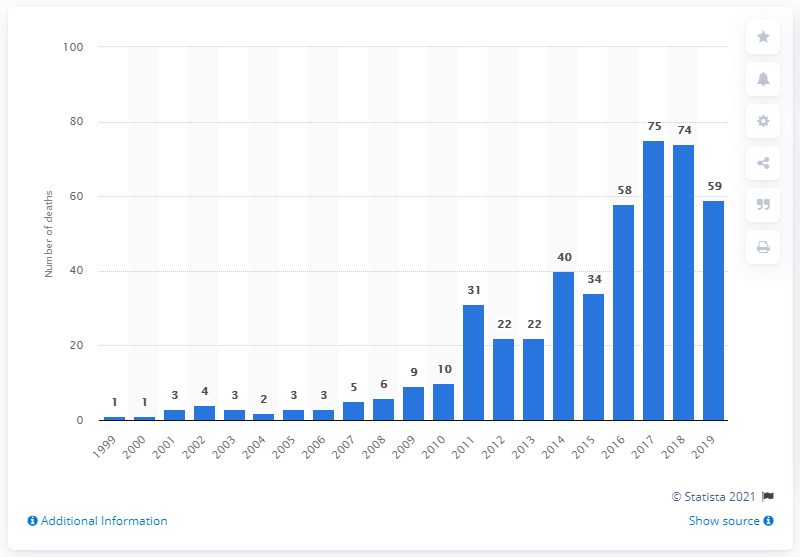Mention a couple of crucial points in this snapshot. In 2017, there were 75 recorded deaths from fentanyl drug poisoning. 